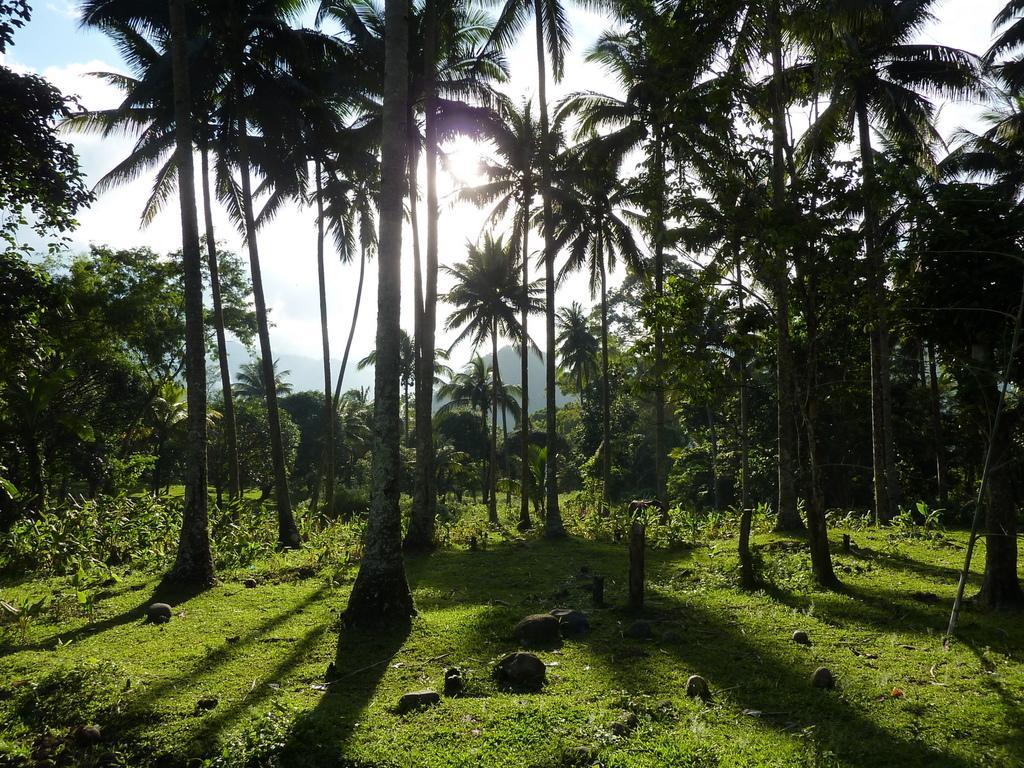Describe this image in one or two sentences. In this image there are coconut trees in the middle. At the bottom there is grass on the ground. There are some small plants in the middle. At the top there is the sky with the clouds. In the middle there is a sun. 